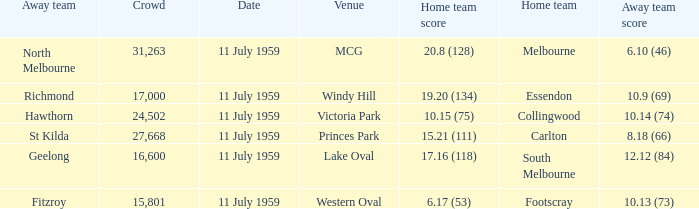How many points does footscray score as the home side? 6.17 (53). 